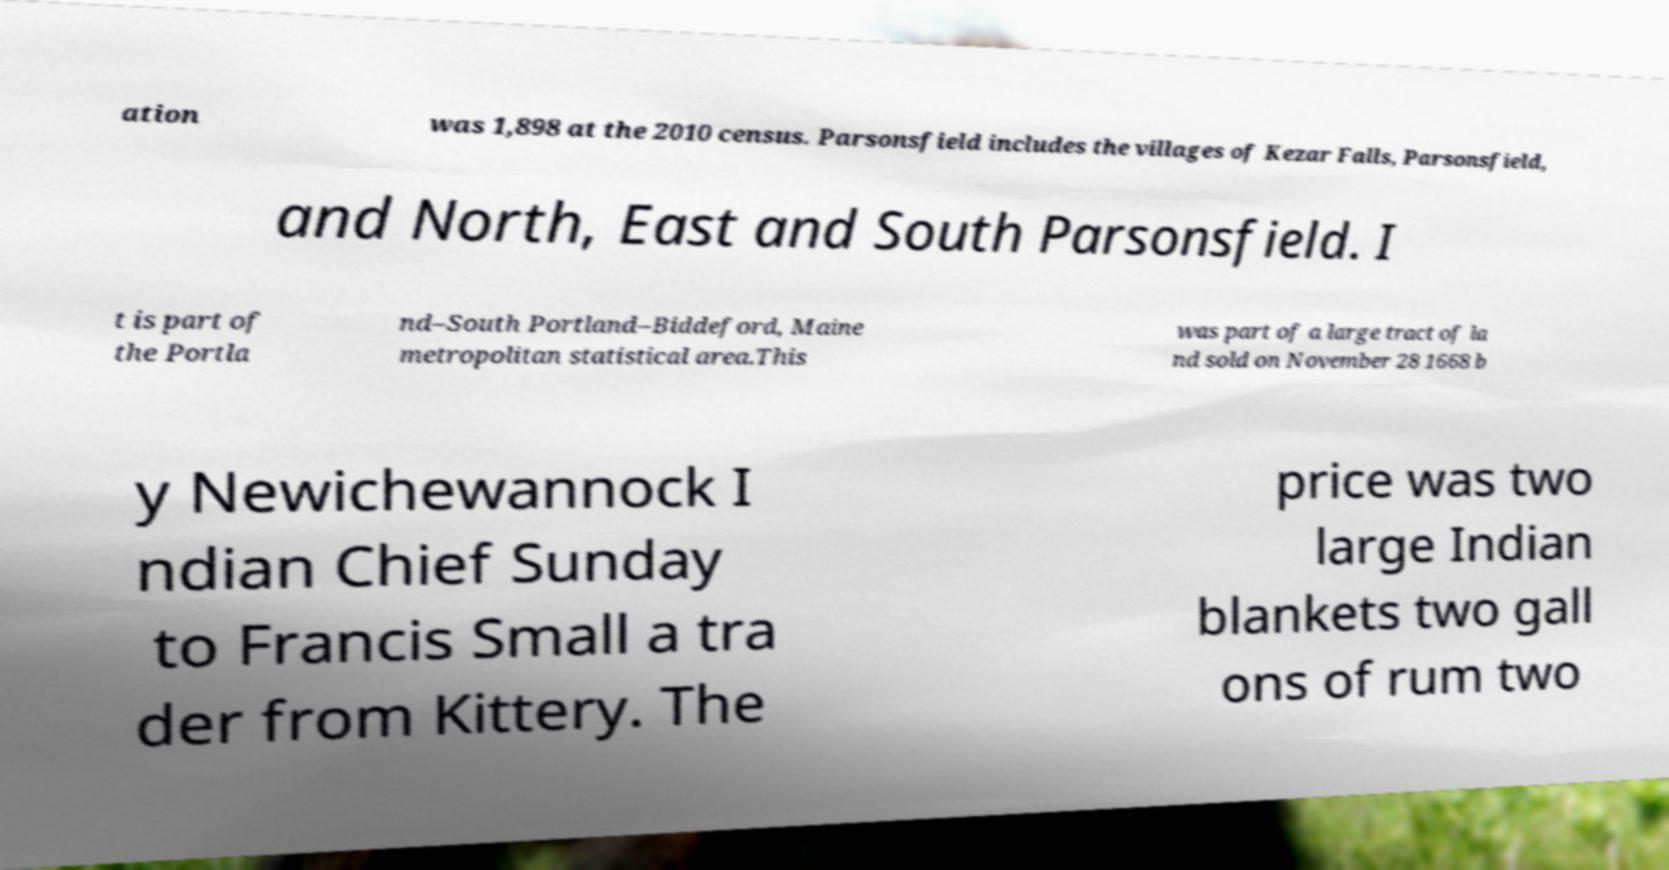What messages or text are displayed in this image? I need them in a readable, typed format. ation was 1,898 at the 2010 census. Parsonsfield includes the villages of Kezar Falls, Parsonsfield, and North, East and South Parsonsfield. I t is part of the Portla nd–South Portland–Biddeford, Maine metropolitan statistical area.This was part of a large tract of la nd sold on November 28 1668 b y Newichewannock I ndian Chief Sunday to Francis Small a tra der from Kittery. The price was two large Indian blankets two gall ons of rum two 